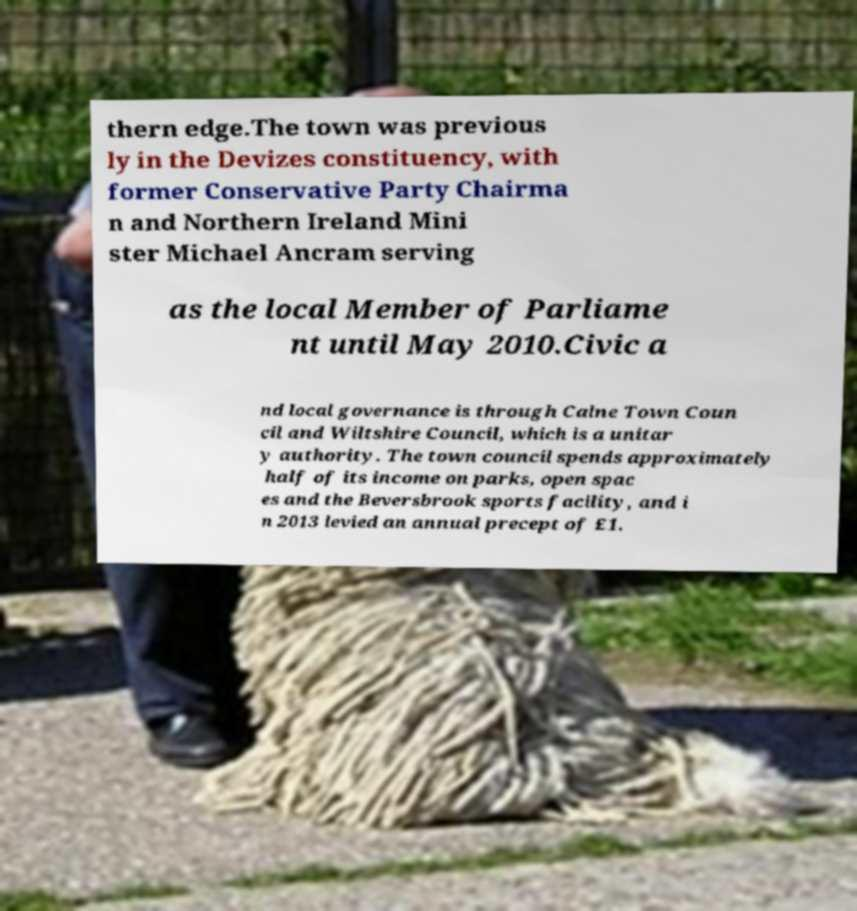What messages or text are displayed in this image? I need them in a readable, typed format. thern edge.The town was previous ly in the Devizes constituency, with former Conservative Party Chairma n and Northern Ireland Mini ster Michael Ancram serving as the local Member of Parliame nt until May 2010.Civic a nd local governance is through Calne Town Coun cil and Wiltshire Council, which is a unitar y authority. The town council spends approximately half of its income on parks, open spac es and the Beversbrook sports facility, and i n 2013 levied an annual precept of £1. 